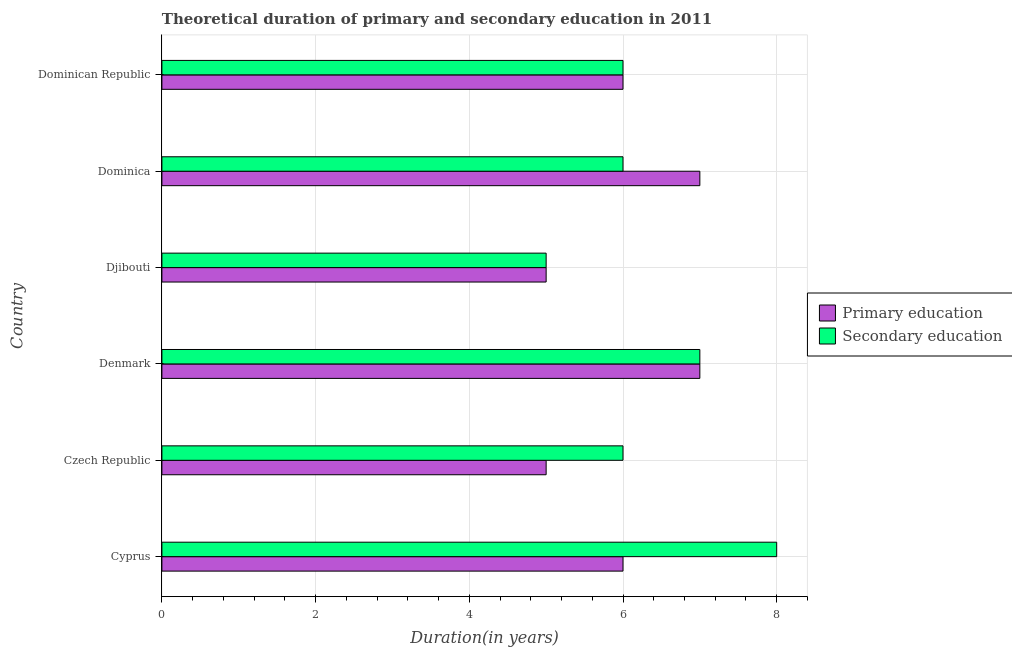How many different coloured bars are there?
Make the answer very short. 2. How many bars are there on the 1st tick from the top?
Make the answer very short. 2. What is the label of the 5th group of bars from the top?
Ensure brevity in your answer.  Czech Republic. What is the duration of primary education in Cyprus?
Your response must be concise. 6. Across all countries, what is the maximum duration of secondary education?
Provide a short and direct response. 8. Across all countries, what is the minimum duration of primary education?
Offer a very short reply. 5. In which country was the duration of primary education maximum?
Your response must be concise. Denmark. In which country was the duration of primary education minimum?
Ensure brevity in your answer.  Czech Republic. What is the total duration of primary education in the graph?
Make the answer very short. 36. What is the difference between the duration of primary education in Djibouti and that in Dominica?
Provide a succinct answer. -2. What is the difference between the duration of primary education in Dominican Republic and the duration of secondary education in Denmark?
Give a very brief answer. -1. What is the average duration of primary education per country?
Make the answer very short. 6. In how many countries, is the duration of primary education greater than 7.6 years?
Provide a short and direct response. 0. What is the ratio of the duration of primary education in Cyprus to that in Czech Republic?
Give a very brief answer. 1.2. Is the duration of secondary education in Cyprus less than that in Dominican Republic?
Your answer should be compact. No. Is the difference between the duration of primary education in Czech Republic and Denmark greater than the difference between the duration of secondary education in Czech Republic and Denmark?
Ensure brevity in your answer.  No. What is the difference between the highest and the lowest duration of primary education?
Provide a succinct answer. 2. In how many countries, is the duration of secondary education greater than the average duration of secondary education taken over all countries?
Provide a succinct answer. 2. What does the 1st bar from the top in Denmark represents?
Offer a very short reply. Secondary education. What does the 1st bar from the bottom in Djibouti represents?
Your response must be concise. Primary education. How many bars are there?
Your answer should be very brief. 12. Are all the bars in the graph horizontal?
Provide a succinct answer. Yes. How many countries are there in the graph?
Keep it short and to the point. 6. What is the difference between two consecutive major ticks on the X-axis?
Provide a short and direct response. 2. Does the graph contain any zero values?
Offer a very short reply. No. How are the legend labels stacked?
Offer a terse response. Vertical. What is the title of the graph?
Your response must be concise. Theoretical duration of primary and secondary education in 2011. What is the label or title of the X-axis?
Your response must be concise. Duration(in years). What is the label or title of the Y-axis?
Provide a succinct answer. Country. What is the Duration(in years) of Secondary education in Cyprus?
Offer a terse response. 8. What is the Duration(in years) in Primary education in Djibouti?
Your answer should be compact. 5. What is the Duration(in years) of Secondary education in Djibouti?
Provide a short and direct response. 5. What is the Duration(in years) in Primary education in Dominican Republic?
Give a very brief answer. 6. Across all countries, what is the maximum Duration(in years) of Primary education?
Make the answer very short. 7. Across all countries, what is the minimum Duration(in years) in Secondary education?
Your answer should be compact. 5. What is the total Duration(in years) in Primary education in the graph?
Make the answer very short. 36. What is the difference between the Duration(in years) in Secondary education in Cyprus and that in Czech Republic?
Provide a short and direct response. 2. What is the difference between the Duration(in years) of Primary education in Cyprus and that in Denmark?
Provide a succinct answer. -1. What is the difference between the Duration(in years) of Secondary education in Cyprus and that in Djibouti?
Ensure brevity in your answer.  3. What is the difference between the Duration(in years) in Primary education in Cyprus and that in Dominica?
Offer a terse response. -1. What is the difference between the Duration(in years) in Secondary education in Cyprus and that in Dominica?
Provide a short and direct response. 2. What is the difference between the Duration(in years) in Primary education in Czech Republic and that in Djibouti?
Your response must be concise. 0. What is the difference between the Duration(in years) of Secondary education in Czech Republic and that in Djibouti?
Offer a very short reply. 1. What is the difference between the Duration(in years) in Primary education in Czech Republic and that in Dominica?
Your answer should be very brief. -2. What is the difference between the Duration(in years) of Secondary education in Czech Republic and that in Dominica?
Offer a terse response. 0. What is the difference between the Duration(in years) in Primary education in Czech Republic and that in Dominican Republic?
Offer a very short reply. -1. What is the difference between the Duration(in years) of Secondary education in Czech Republic and that in Dominican Republic?
Keep it short and to the point. 0. What is the difference between the Duration(in years) in Primary education in Denmark and that in Djibouti?
Your response must be concise. 2. What is the difference between the Duration(in years) in Secondary education in Denmark and that in Djibouti?
Ensure brevity in your answer.  2. What is the difference between the Duration(in years) in Primary education in Denmark and that in Dominica?
Provide a succinct answer. 0. What is the difference between the Duration(in years) of Secondary education in Denmark and that in Dominica?
Offer a very short reply. 1. What is the difference between the Duration(in years) of Primary education in Denmark and that in Dominican Republic?
Make the answer very short. 1. What is the difference between the Duration(in years) of Secondary education in Denmark and that in Dominican Republic?
Offer a terse response. 1. What is the difference between the Duration(in years) in Secondary education in Dominica and that in Dominican Republic?
Your answer should be very brief. 0. What is the difference between the Duration(in years) of Primary education in Cyprus and the Duration(in years) of Secondary education in Czech Republic?
Provide a short and direct response. 0. What is the difference between the Duration(in years) in Primary education in Cyprus and the Duration(in years) in Secondary education in Denmark?
Offer a terse response. -1. What is the difference between the Duration(in years) in Primary education in Djibouti and the Duration(in years) in Secondary education in Dominica?
Keep it short and to the point. -1. What is the average Duration(in years) of Primary education per country?
Your answer should be compact. 6. What is the average Duration(in years) in Secondary education per country?
Offer a terse response. 6.33. What is the difference between the Duration(in years) of Primary education and Duration(in years) of Secondary education in Czech Republic?
Provide a succinct answer. -1. What is the difference between the Duration(in years) of Primary education and Duration(in years) of Secondary education in Dominica?
Ensure brevity in your answer.  1. What is the ratio of the Duration(in years) of Primary education in Cyprus to that in Denmark?
Offer a terse response. 0.86. What is the ratio of the Duration(in years) of Secondary education in Cyprus to that in Djibouti?
Give a very brief answer. 1.6. What is the ratio of the Duration(in years) in Primary education in Cyprus to that in Dominica?
Offer a very short reply. 0.86. What is the ratio of the Duration(in years) in Secondary education in Cyprus to that in Dominica?
Your answer should be very brief. 1.33. What is the ratio of the Duration(in years) in Secondary education in Cyprus to that in Dominican Republic?
Make the answer very short. 1.33. What is the ratio of the Duration(in years) in Secondary education in Czech Republic to that in Denmark?
Ensure brevity in your answer.  0.86. What is the ratio of the Duration(in years) of Primary education in Czech Republic to that in Djibouti?
Keep it short and to the point. 1. What is the ratio of the Duration(in years) of Secondary education in Czech Republic to that in Djibouti?
Make the answer very short. 1.2. What is the ratio of the Duration(in years) in Primary education in Czech Republic to that in Dominican Republic?
Make the answer very short. 0.83. What is the ratio of the Duration(in years) in Primary education in Denmark to that in Djibouti?
Provide a short and direct response. 1.4. What is the ratio of the Duration(in years) in Secondary education in Denmark to that in Djibouti?
Provide a succinct answer. 1.4. What is the ratio of the Duration(in years) in Primary education in Denmark to that in Dominica?
Make the answer very short. 1. What is the ratio of the Duration(in years) in Secondary education in Denmark to that in Dominica?
Provide a short and direct response. 1.17. What is the ratio of the Duration(in years) in Primary education in Djibouti to that in Dominica?
Make the answer very short. 0.71. What is the ratio of the Duration(in years) in Secondary education in Djibouti to that in Dominica?
Your answer should be compact. 0.83. What is the ratio of the Duration(in years) in Primary education in Djibouti to that in Dominican Republic?
Keep it short and to the point. 0.83. What is the ratio of the Duration(in years) in Secondary education in Djibouti to that in Dominican Republic?
Your answer should be very brief. 0.83. 